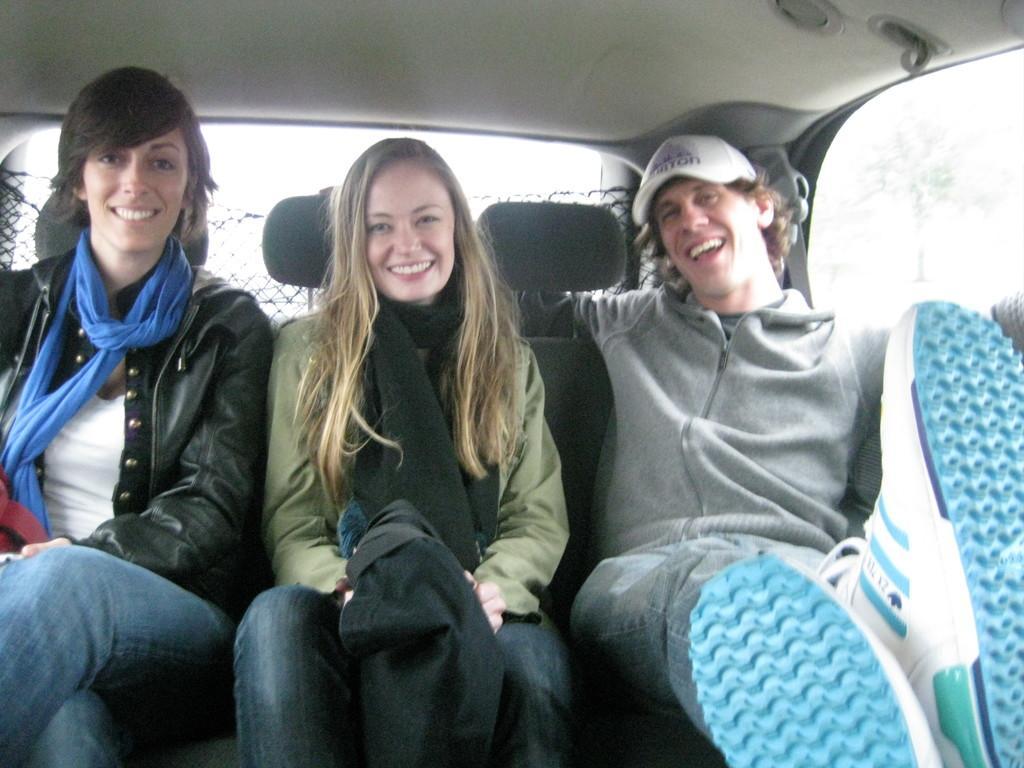In one or two sentences, can you explain what this image depicts? Here we can see three people sitting in a car and all of them are smiling and the person on the right is wearing a cap 